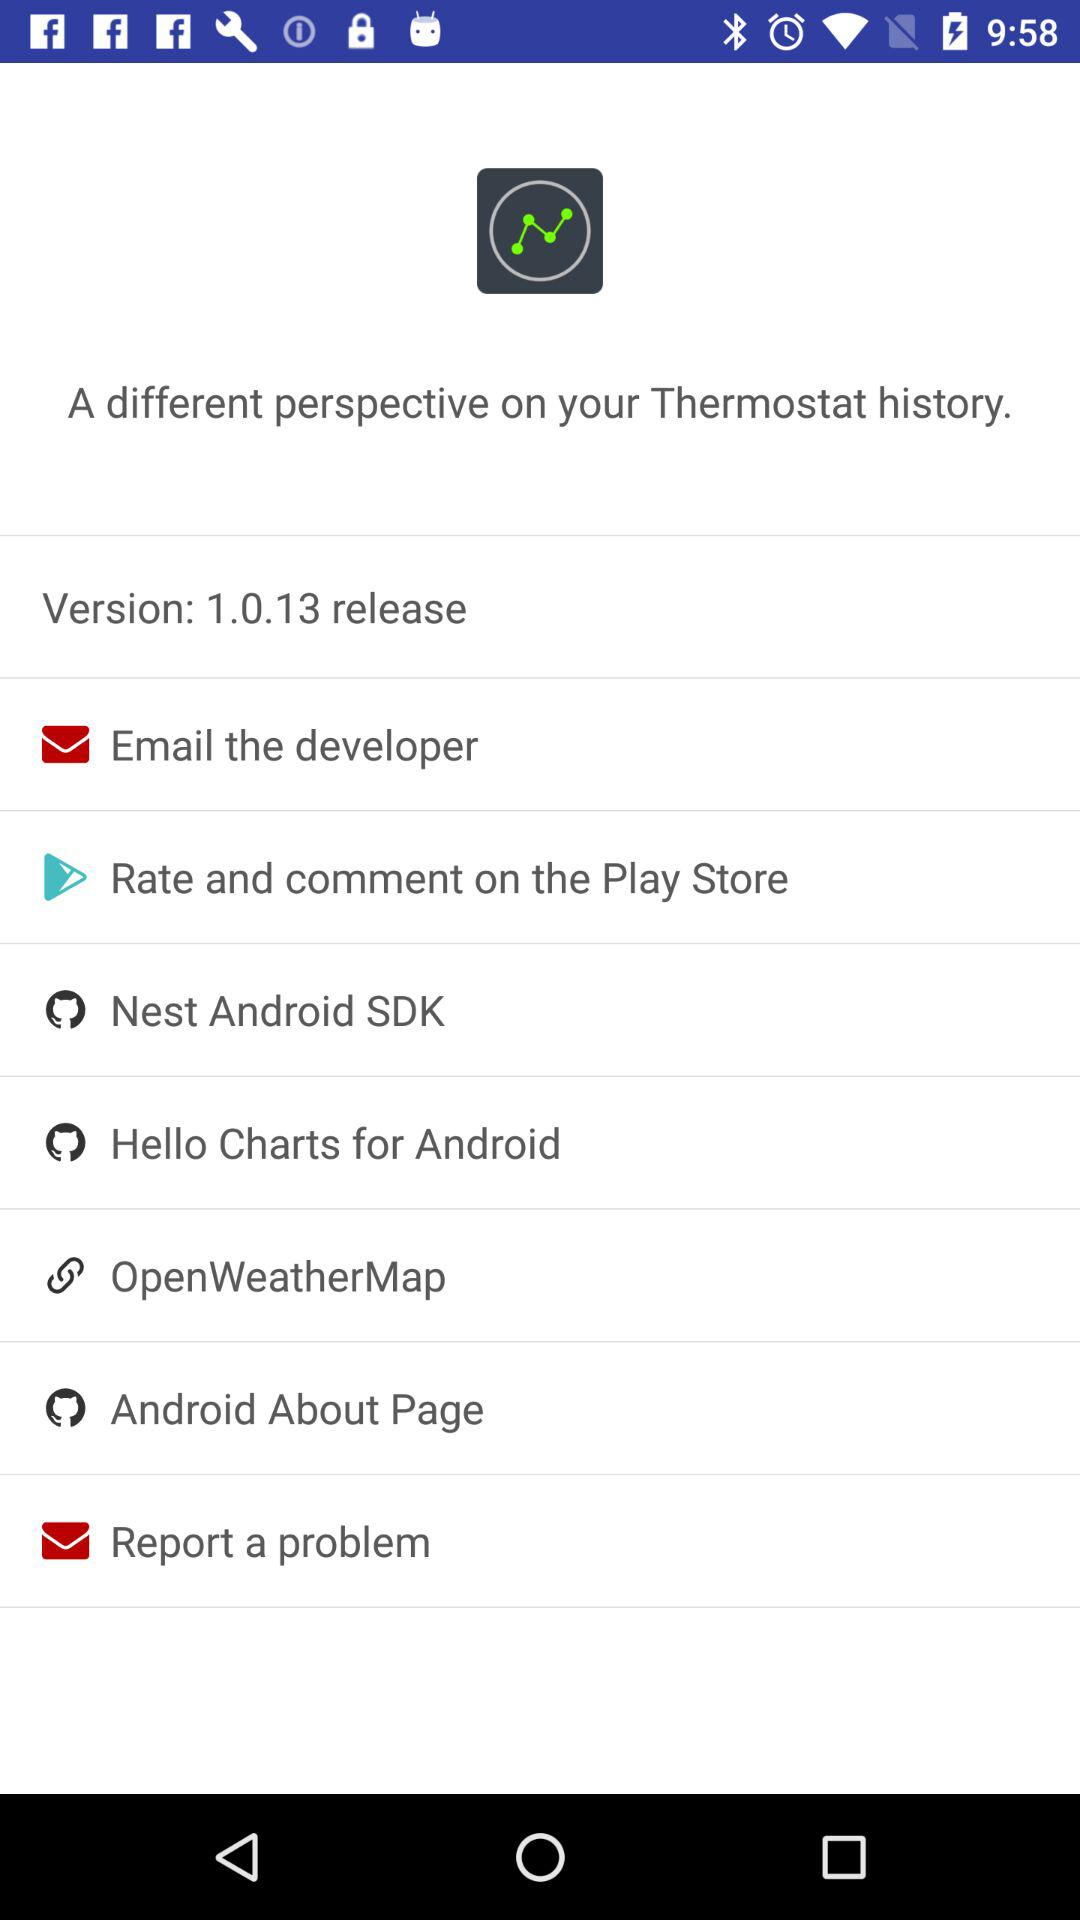What is the version of the application? The version of the application is 1.0.13. 